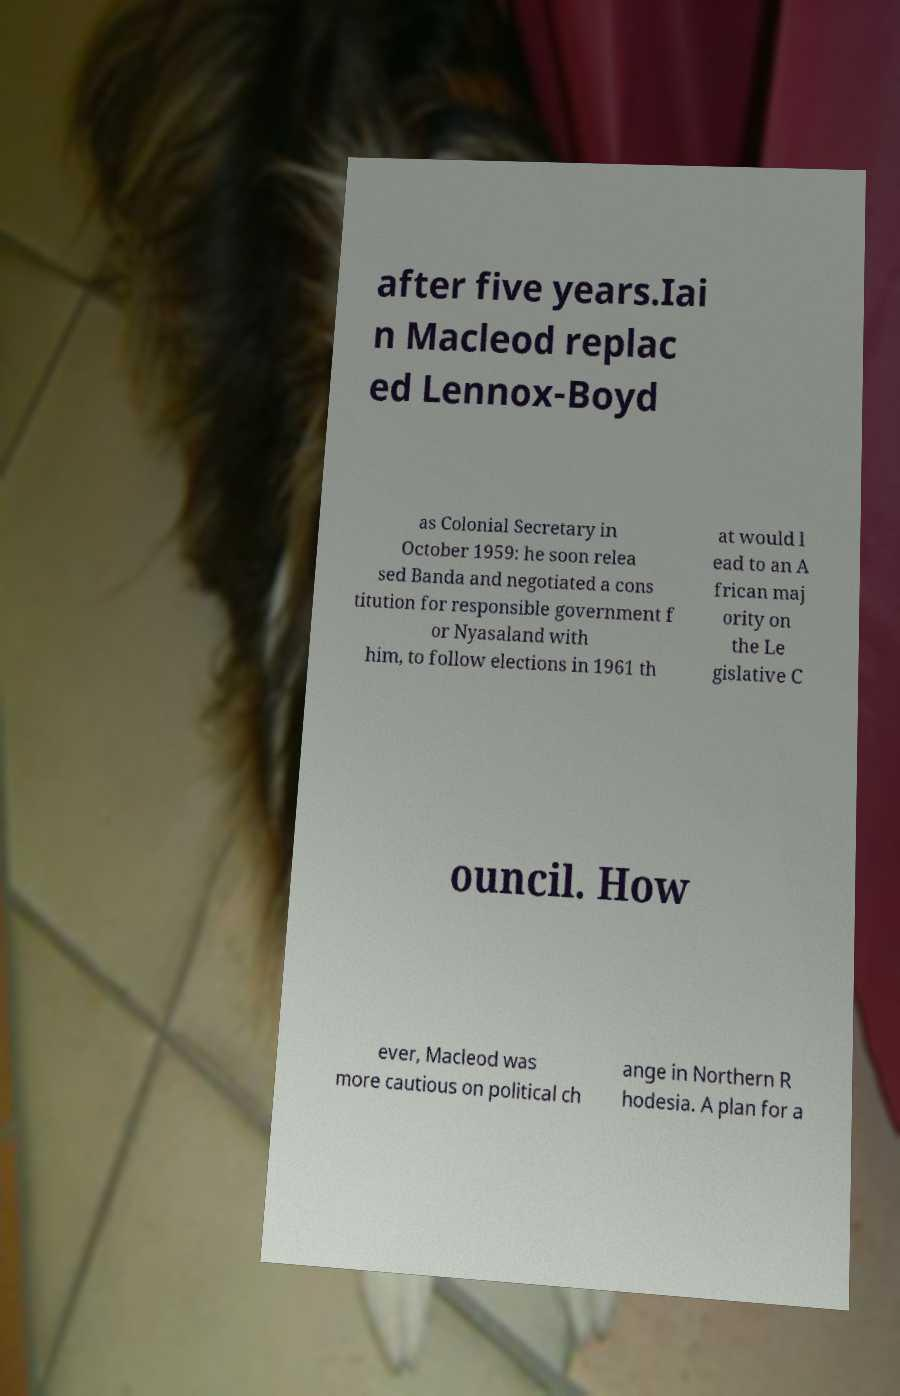Please read and relay the text visible in this image. What does it say? after five years.Iai n Macleod replac ed Lennox-Boyd as Colonial Secretary in October 1959: he soon relea sed Banda and negotiated a cons titution for responsible government f or Nyasaland with him, to follow elections in 1961 th at would l ead to an A frican maj ority on the Le gislative C ouncil. How ever, Macleod was more cautious on political ch ange in Northern R hodesia. A plan for a 